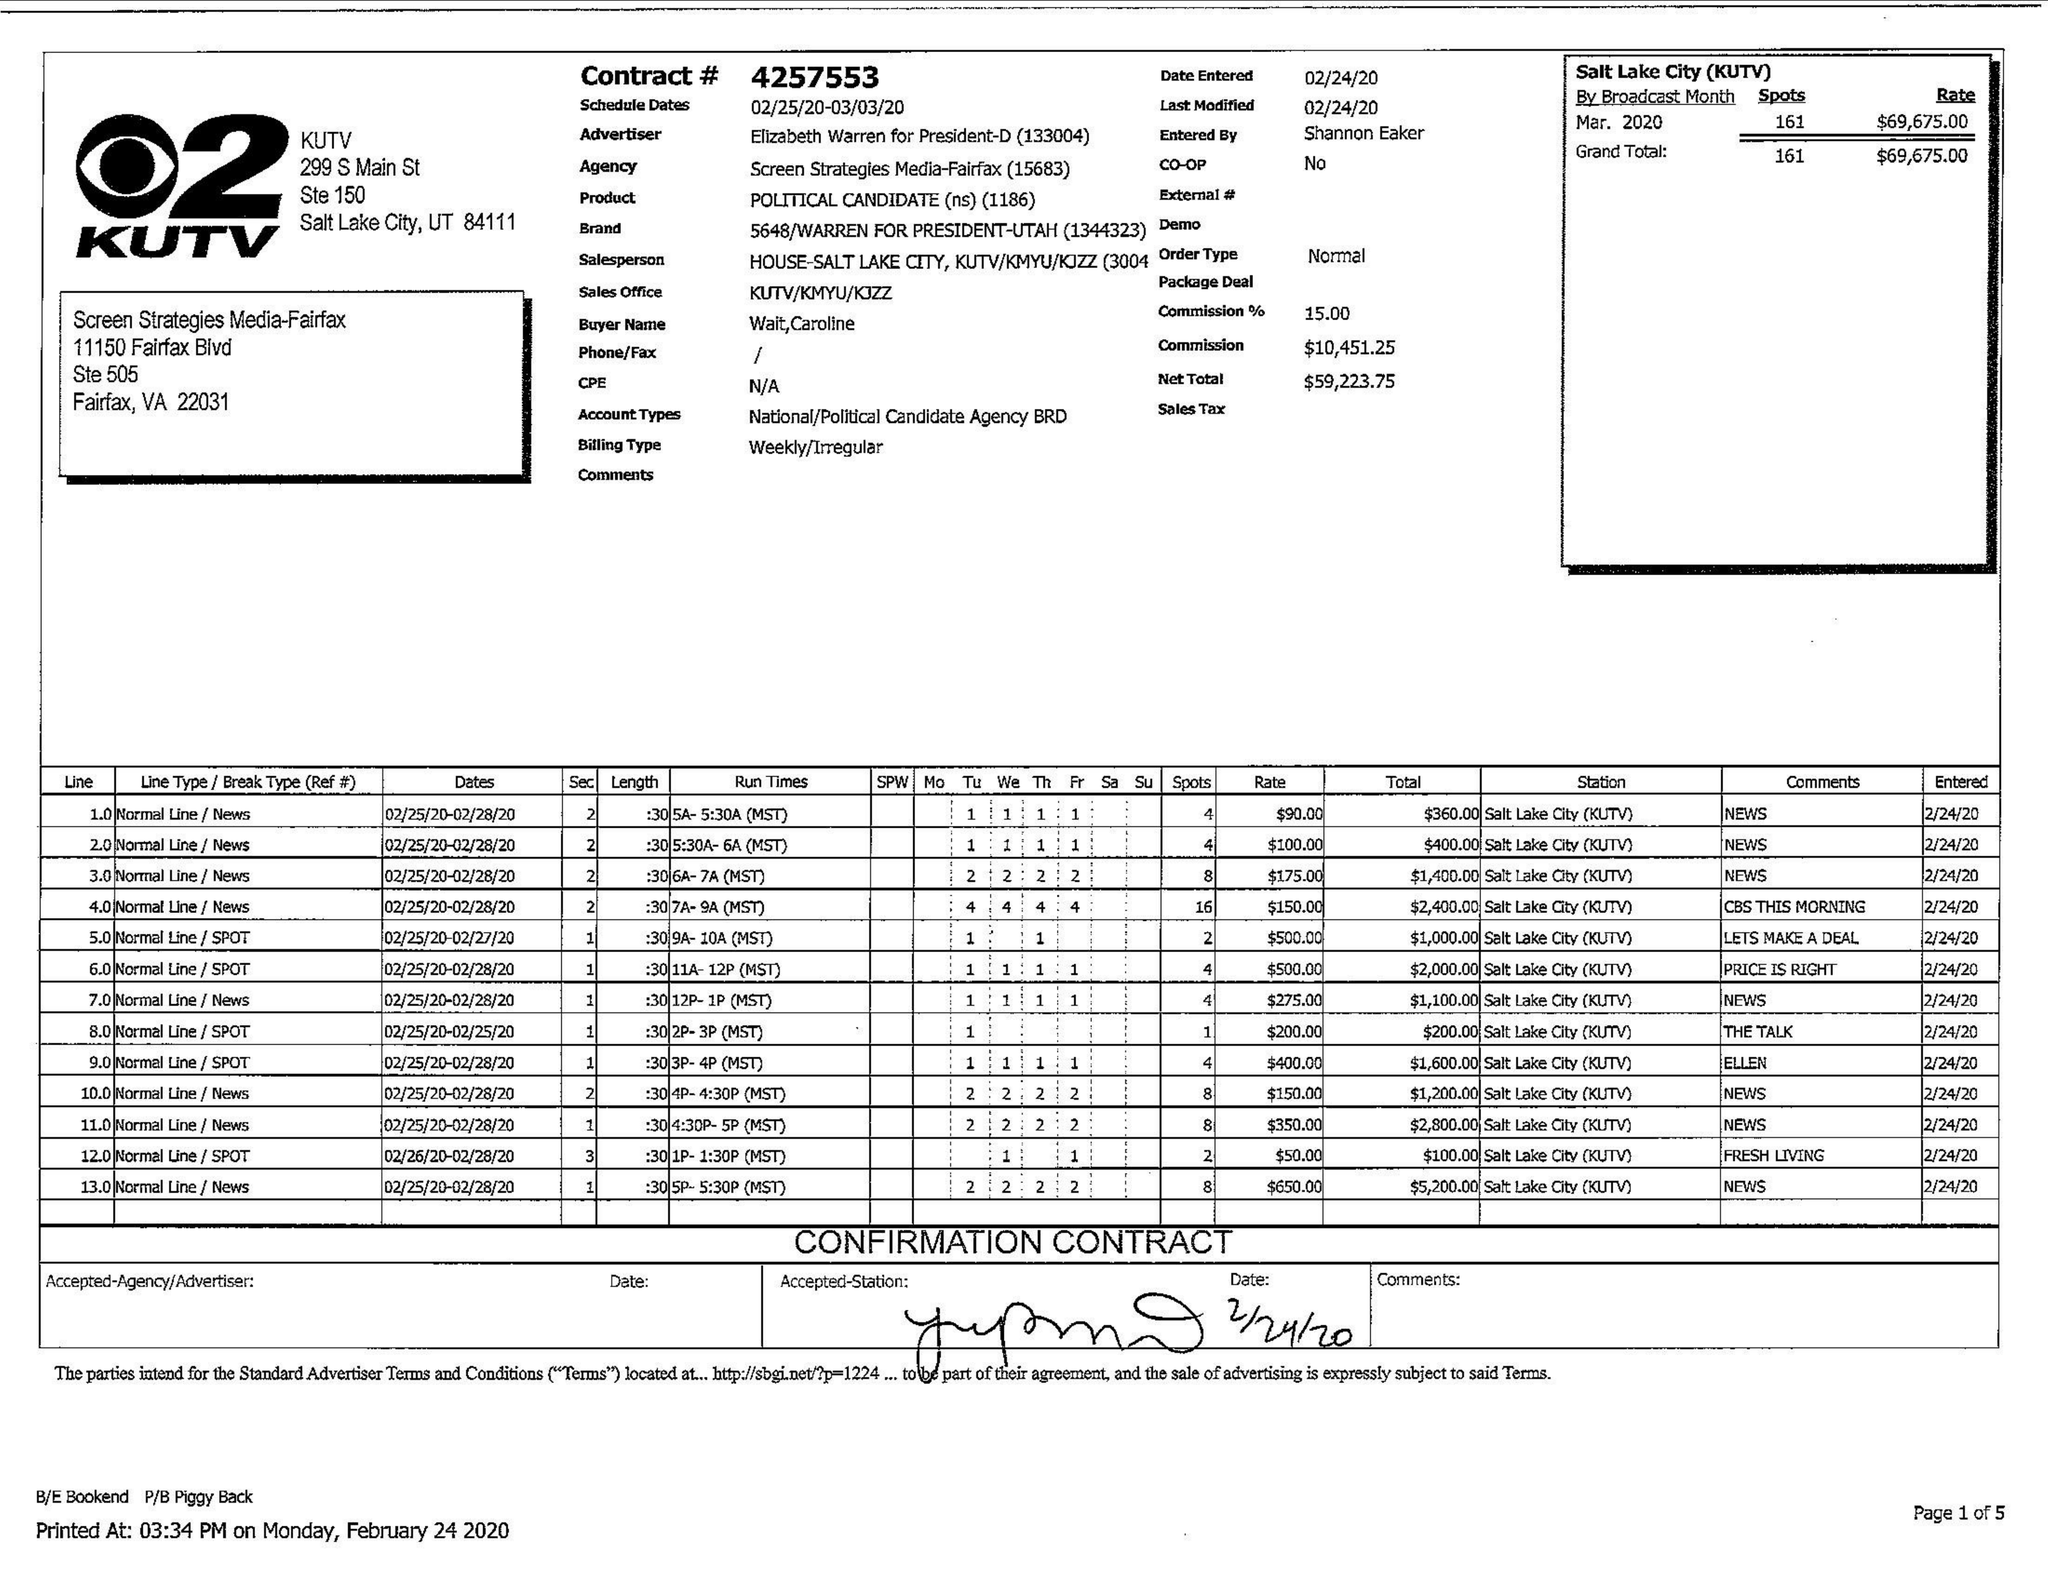What is the value for the flight_from?
Answer the question using a single word or phrase. 02/25/20 